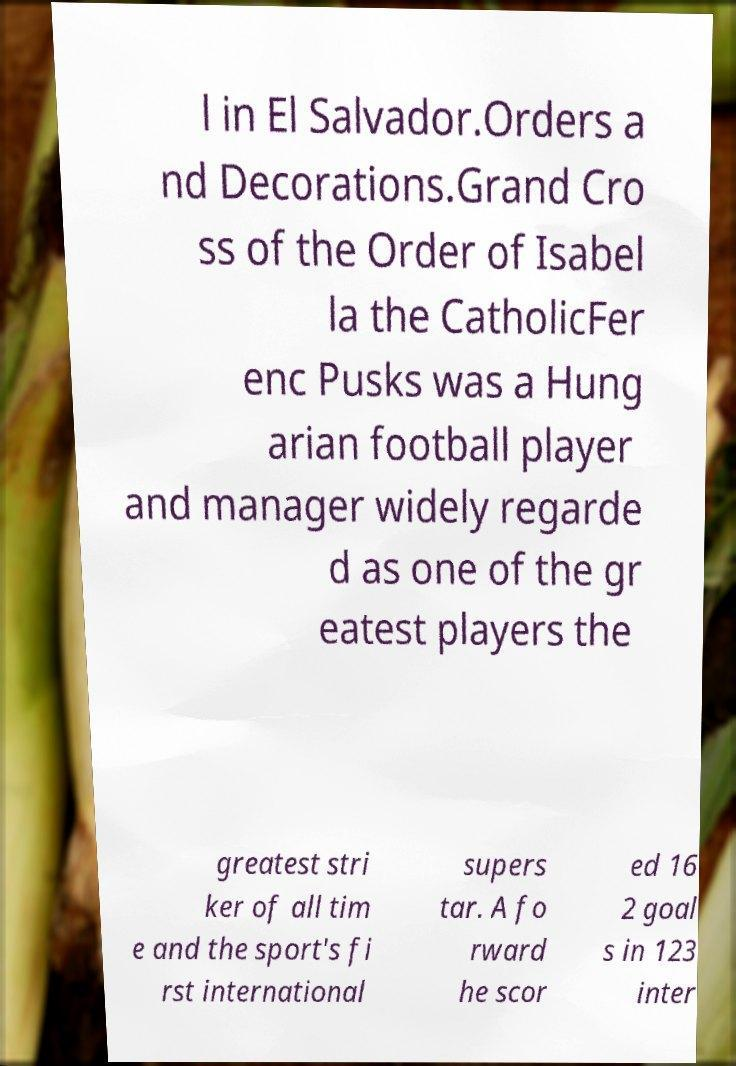Could you assist in decoding the text presented in this image and type it out clearly? l in El Salvador.Orders a nd Decorations.Grand Cro ss of the Order of Isabel la the CatholicFer enc Pusks was a Hung arian football player and manager widely regarde d as one of the gr eatest players the greatest stri ker of all tim e and the sport's fi rst international supers tar. A fo rward he scor ed 16 2 goal s in 123 inter 